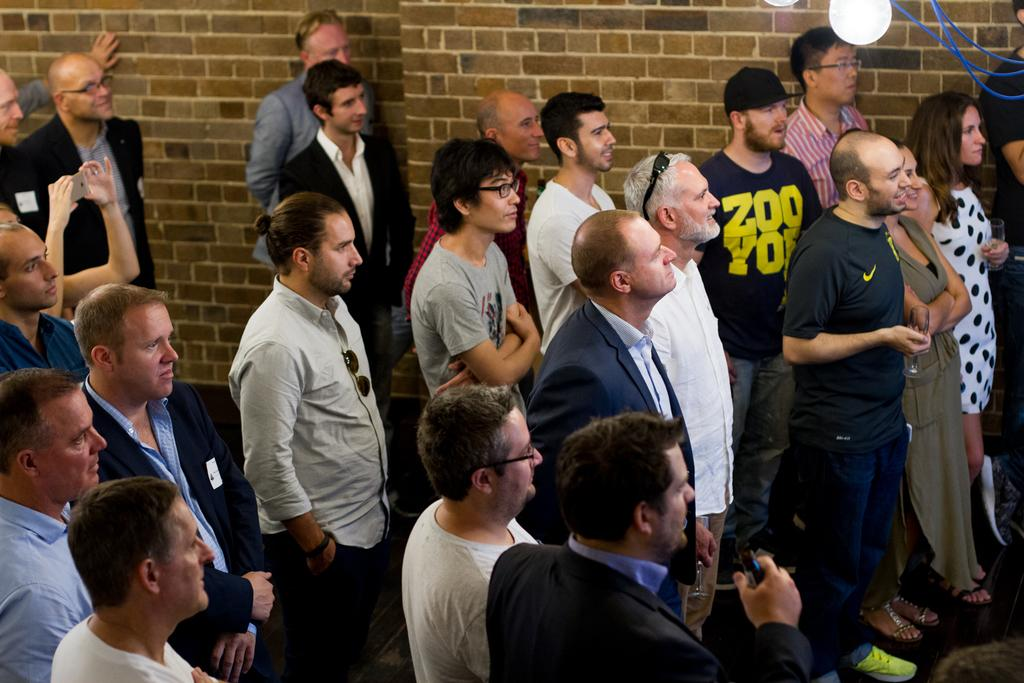Who or what can be seen in the image? There are people in the image. What is visible in the background of the image? There is a wall in the background of the image. What can be seen at the top of the image? There are lights visible at the top of the image. What type of lace is being used to decorate the wall in the image? There is no lace visible on the wall in the image. Can you tell me which type of berry is being held by one of the people in the image? There is no berry visible in the image. 